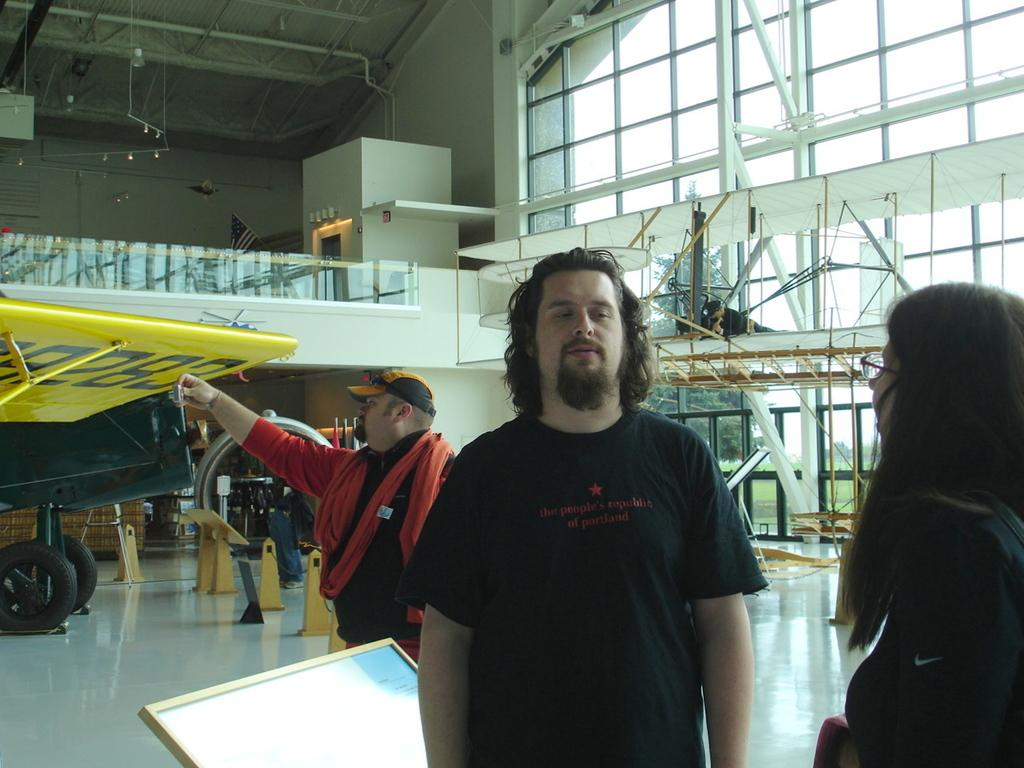What are the people in the image doing? The people in the image are standing on the floor. What object can be seen in the image besides the people? There is a board and a vehicle in the image. What is the position of the man in the image? The man is lying on a platform in the image. What can be seen in the background of the image? Trees and the sky are visible in the background of the image. What type of sweater is the man wearing in the image? There is no mention of a sweater in the image, so it cannot be determined what type of sweater the man might be wearing. How many clovers are visible on the platform where the man is lying? There are no clovers present in the image; the man is lying on a platform, but there is no mention of clovers. 